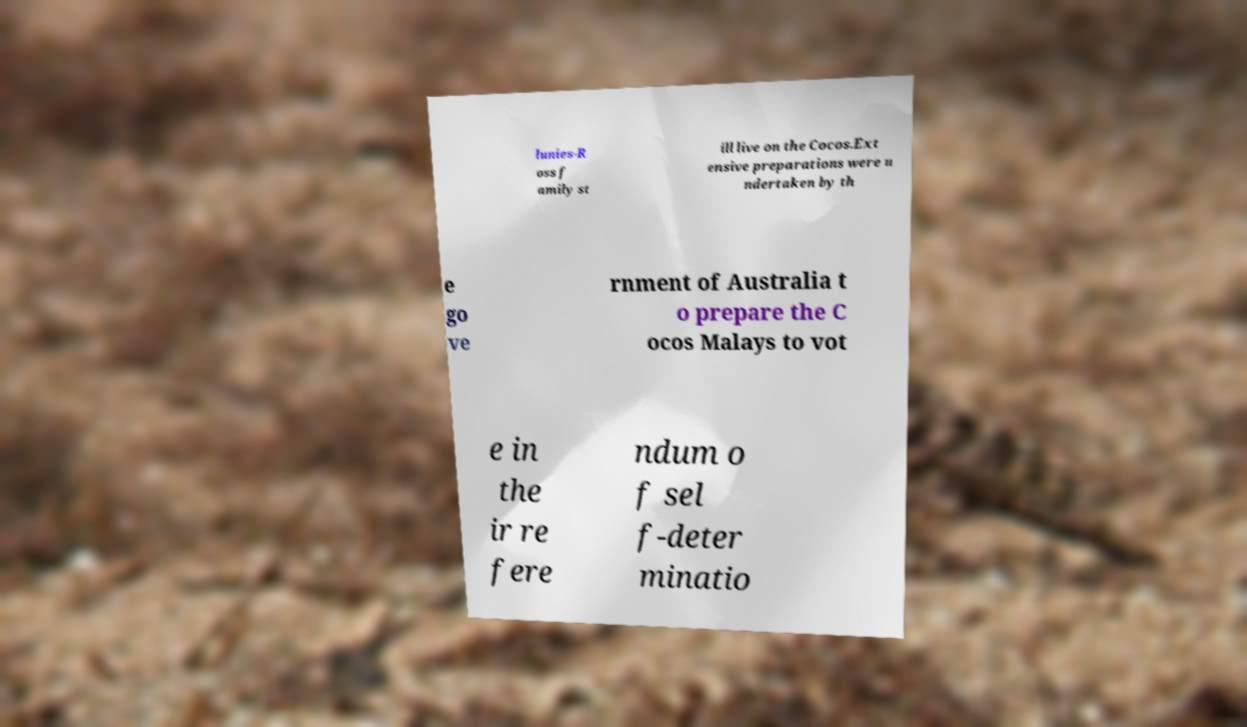There's text embedded in this image that I need extracted. Can you transcribe it verbatim? lunies-R oss f amily st ill live on the Cocos.Ext ensive preparations were u ndertaken by th e go ve rnment of Australia t o prepare the C ocos Malays to vot e in the ir re fere ndum o f sel f-deter minatio 